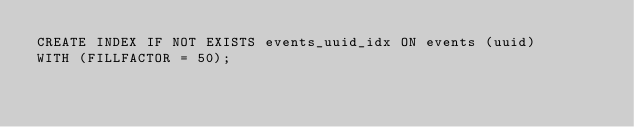Convert code to text. <code><loc_0><loc_0><loc_500><loc_500><_SQL_>CREATE INDEX IF NOT EXISTS events_uuid_idx ON events (uuid)
WITH (FILLFACTOR = 50);
</code> 